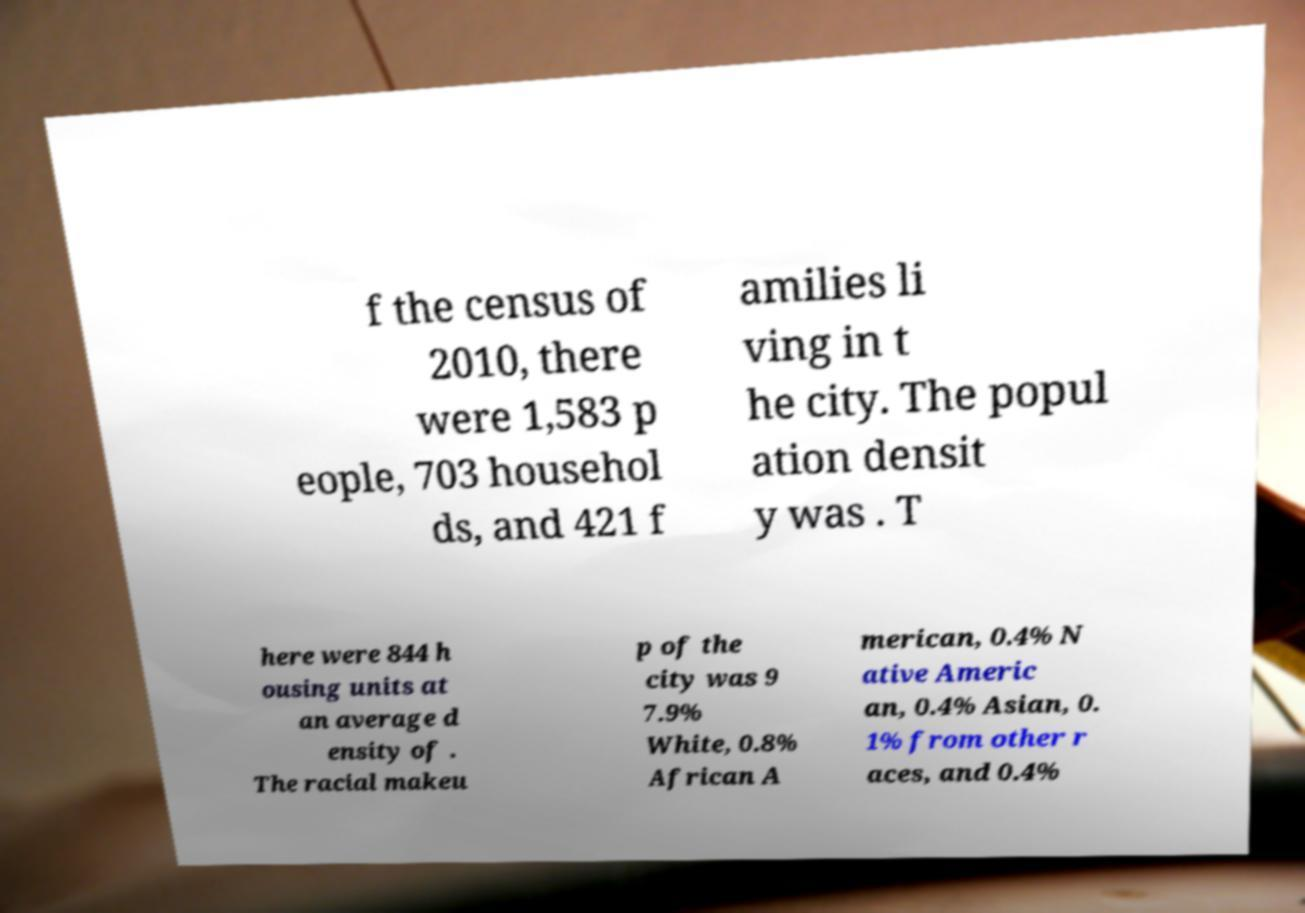For documentation purposes, I need the text within this image transcribed. Could you provide that? f the census of 2010, there were 1,583 p eople, 703 househol ds, and 421 f amilies li ving in t he city. The popul ation densit y was . T here were 844 h ousing units at an average d ensity of . The racial makeu p of the city was 9 7.9% White, 0.8% African A merican, 0.4% N ative Americ an, 0.4% Asian, 0. 1% from other r aces, and 0.4% 